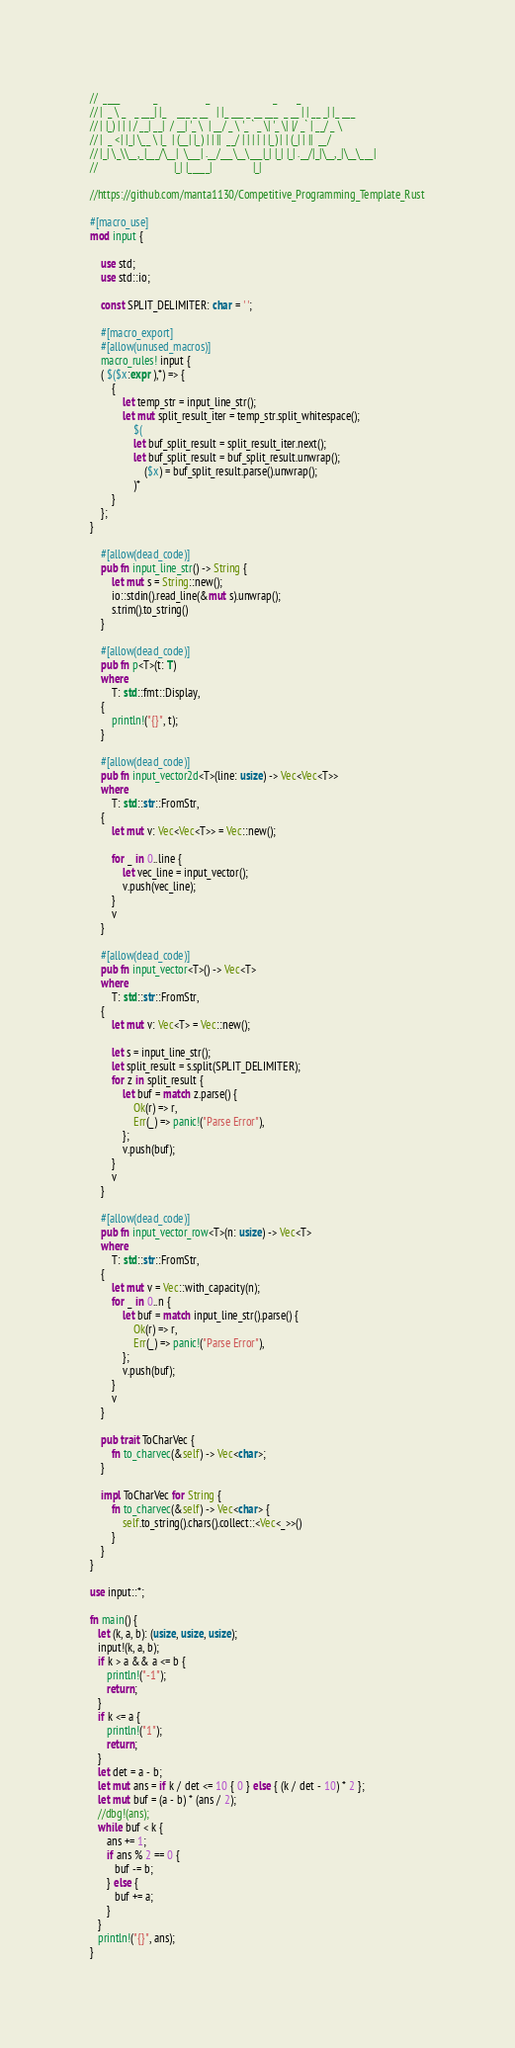<code> <loc_0><loc_0><loc_500><loc_500><_Rust_>//  ____            _                  _                       _       _
// |  _ \ _   _ ___| |_    ___ _ __   | |_ ___ _ __ ___  _ __ | | __ _| |_ ___
// | |_) | | | / __| __|  / __| '_ \  | __/ _ \ '_ ` _ \| '_ \| |/ _` | __/ _ \
// |  _ <| |_| \__ \ |_  | (__| |_) | | ||  __/ | | | | | |_) | | (_| | ||  __/
// |_| \_\\__,_|___/\__|  \___| .__/___\__\___|_| |_| |_| .__/|_|\__,_|\__\___|
//                            |_| |_____|               |_|

//https://github.com/manta1130/Competitive_Programming_Template_Rust

#[macro_use]
mod input {

    use std;
    use std::io;

    const SPLIT_DELIMITER: char = ' ';

    #[macro_export]
    #[allow(unused_macros)]
    macro_rules! input {
    ( $($x:expr ),*) => {
        {
            let temp_str = input_line_str();
            let mut split_result_iter = temp_str.split_whitespace();
                $(
                let buf_split_result = split_result_iter.next();
                let buf_split_result = buf_split_result.unwrap();
                    ($x) = buf_split_result.parse().unwrap();
                )*
        }
    };
}

    #[allow(dead_code)]
    pub fn input_line_str() -> String {
        let mut s = String::new();
        io::stdin().read_line(&mut s).unwrap();
        s.trim().to_string()
    }

    #[allow(dead_code)]
    pub fn p<T>(t: T)
    where
        T: std::fmt::Display,
    {
        println!("{}", t);
    }

    #[allow(dead_code)]
    pub fn input_vector2d<T>(line: usize) -> Vec<Vec<T>>
    where
        T: std::str::FromStr,
    {
        let mut v: Vec<Vec<T>> = Vec::new();

        for _ in 0..line {
            let vec_line = input_vector();
            v.push(vec_line);
        }
        v
    }

    #[allow(dead_code)]
    pub fn input_vector<T>() -> Vec<T>
    where
        T: std::str::FromStr,
    {
        let mut v: Vec<T> = Vec::new();

        let s = input_line_str();
        let split_result = s.split(SPLIT_DELIMITER);
        for z in split_result {
            let buf = match z.parse() {
                Ok(r) => r,
                Err(_) => panic!("Parse Error"),
            };
            v.push(buf);
        }
        v
    }

    #[allow(dead_code)]
    pub fn input_vector_row<T>(n: usize) -> Vec<T>
    where
        T: std::str::FromStr,
    {
        let mut v = Vec::with_capacity(n);
        for _ in 0..n {
            let buf = match input_line_str().parse() {
                Ok(r) => r,
                Err(_) => panic!("Parse Error"),
            };
            v.push(buf);
        }
        v
    }

    pub trait ToCharVec {
        fn to_charvec(&self) -> Vec<char>;
    }

    impl ToCharVec for String {
        fn to_charvec(&self) -> Vec<char> {
            self.to_string().chars().collect::<Vec<_>>()
        }
    }
}

use input::*;

fn main() {
   let (k, a, b): (usize, usize, usize);
   input!(k, a, b);
   if k > a && a <= b {
      println!("-1");
      return;
   }
   if k <= a {
      println!("1");
      return;
   }
   let det = a - b;
   let mut ans = if k / det <= 10 { 0 } else { (k / det - 10) * 2 };
   let mut buf = (a - b) * (ans / 2);
   //dbg!(ans);
   while buf < k {
      ans += 1;
      if ans % 2 == 0 {
         buf -= b;
      } else {
         buf += a;
      }
   }
   println!("{}", ans);
}
</code> 